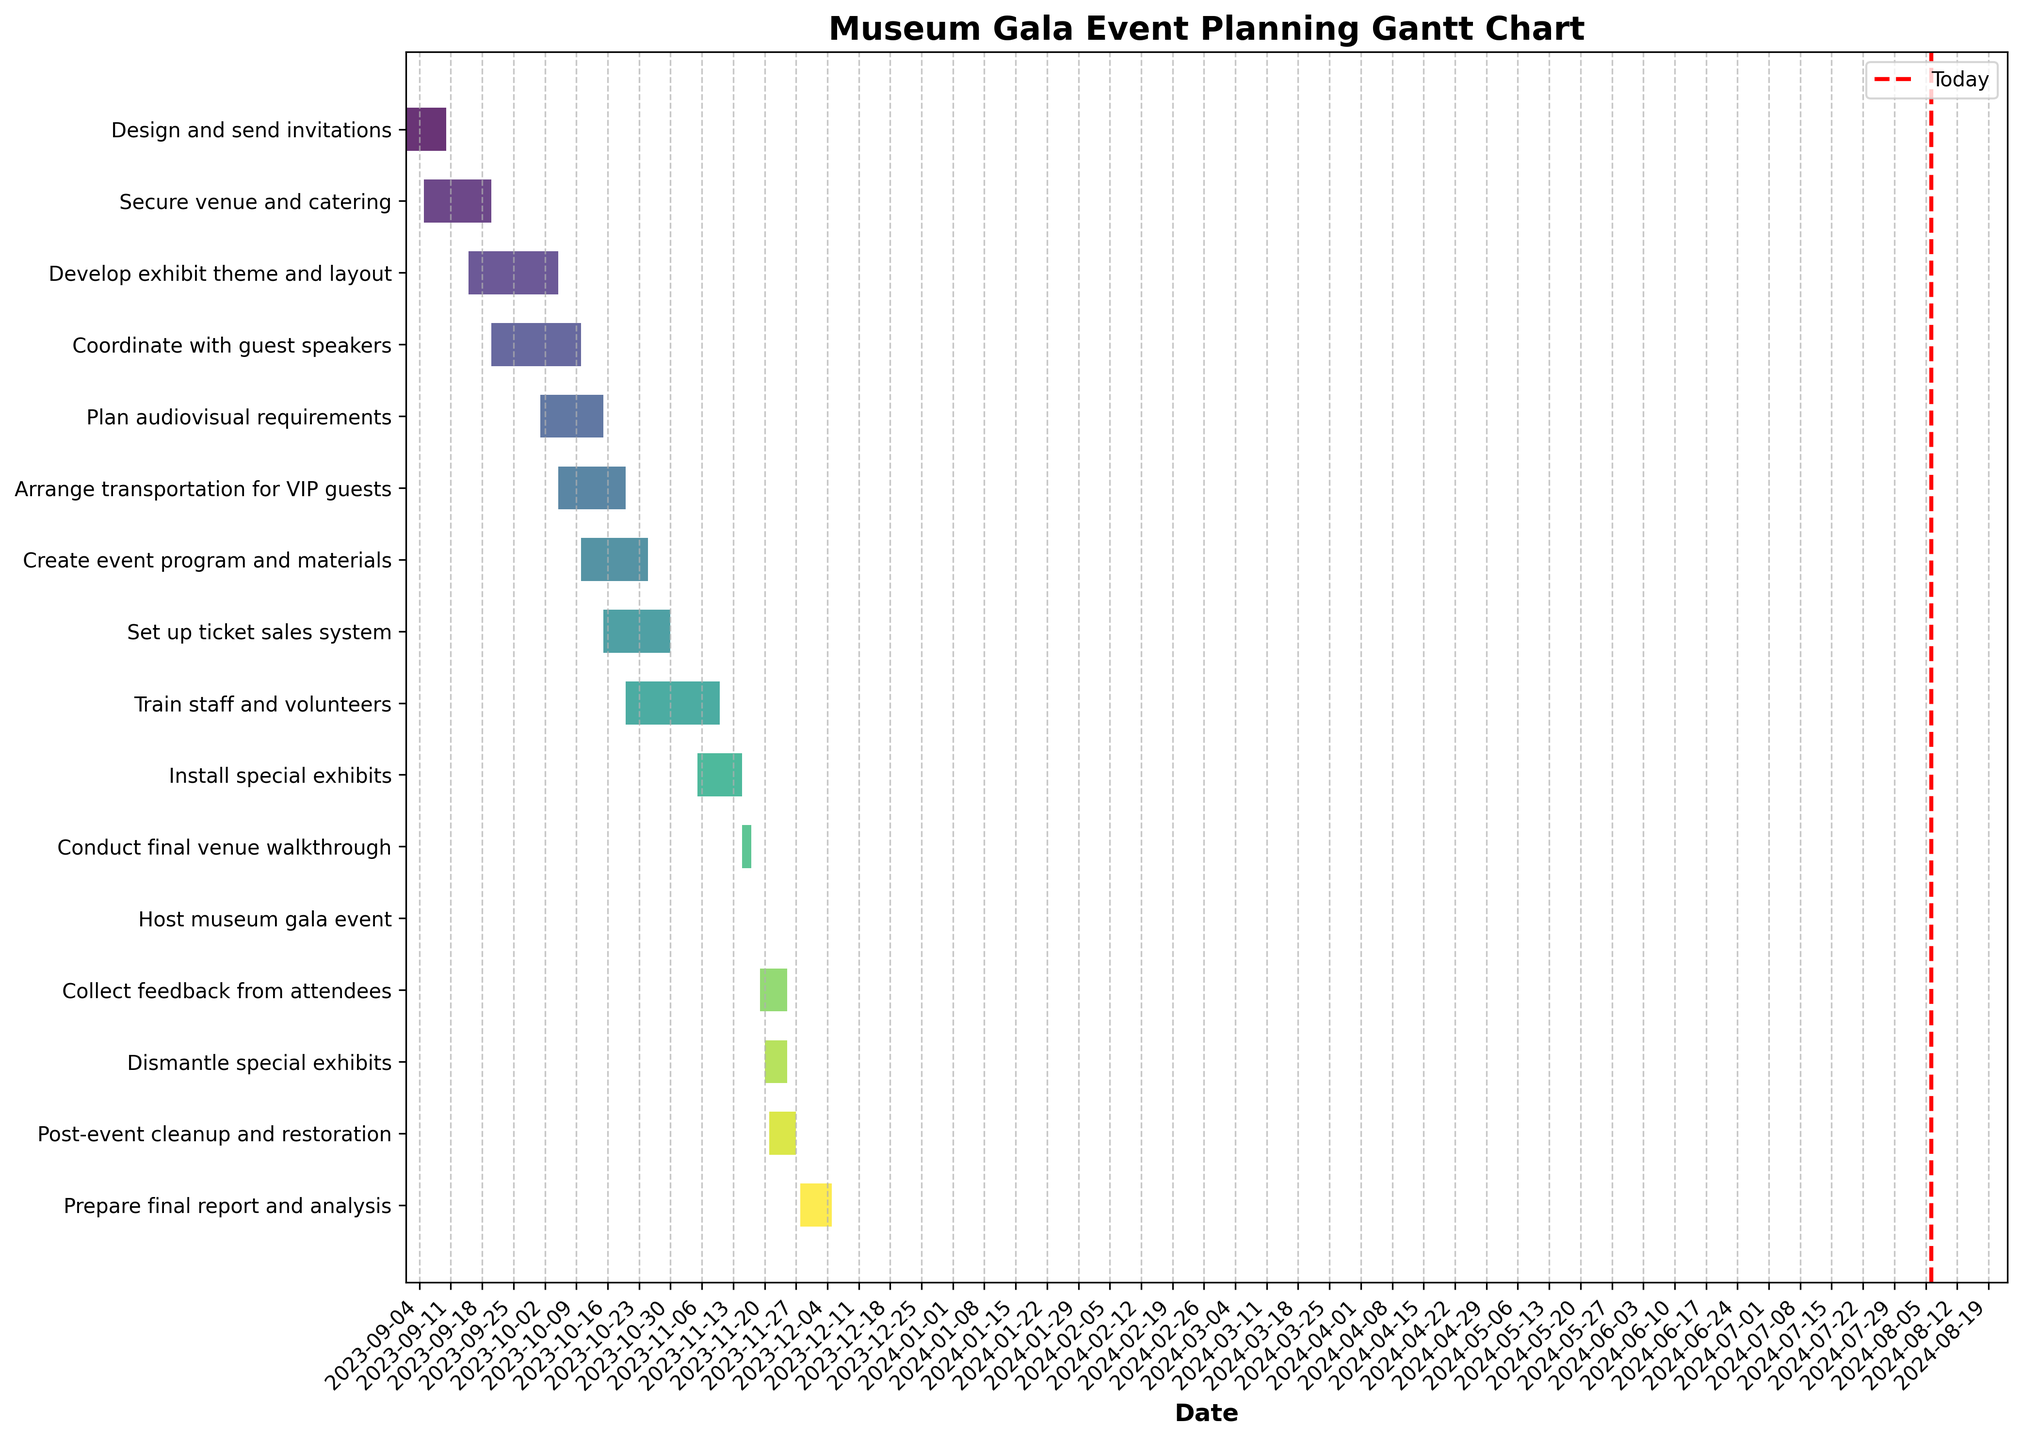How many tasks are listed in the Gantt chart? Count the number of tasks on the y-axis of the chart.
Answer: 15 What is the time range of the task "Coordinate with guest speakers"? Locate the bar representing "Coordinate with guest speakers" and note the start and end dates mentioned.
Answer: September 20 to October 10 Which task has the shortest duration? Identify the task with the shortest bar by comparing the lengths of all bars, and verify the duration mentioned.
Answer: Host museum gala event Which tasks are ongoing today (consider today's date as October 1, 2023)? Check which bars intersect today's date line (red dashed line) on October 1, 2023.
Answer: Secure venue and catering, Develop exhibit theme and layout, Coordinate with guest speakers Which task occurs immediately before "Collect feedback from attendees"? Look at the bar located just above "Collect feedback from attendees" as tasks are sorted by start date.
Answer: Host museum gala event How many tasks overlap with the "Create event program and materials" task? Count all bars that share any portion of their duration with the "Create event program and materials" bar.
Answer: 3 tasks (Plan audiovisual requirements, Arrange transportation for VIP guests, Set up ticket sales system) What is the total duration (in days) of the tasks starting in October? Sum the duration of all tasks that start in October. Add durations of "Plan audiovisual requirements," "Arrange transportation for VIP guests," "Create event program and materials," "Set up ticket sales system," and "Train staff and volunteers."
Answer: 80 days What is the difference in duration between "Install special exhibits" and "Dismantle special exhibits"? Subtract the duration of "Dismantle special exhibits" from that of "Install special exhibits."
Answer: 5 days Which task has the longest duration and what is its total duration in days? Identify the longest bar and verify the duration mentioned.
Answer: Train staff and volunteers, 21 days After the "Host museum gala event," which tasks are scheduled? List all tasks that begin after November 18, 2023, the day the gala is hosted.
Answer: Collect feedback from attendees, Dismantle special exhibits, Post-event cleanup and restoration, Prepare final report and analysis 